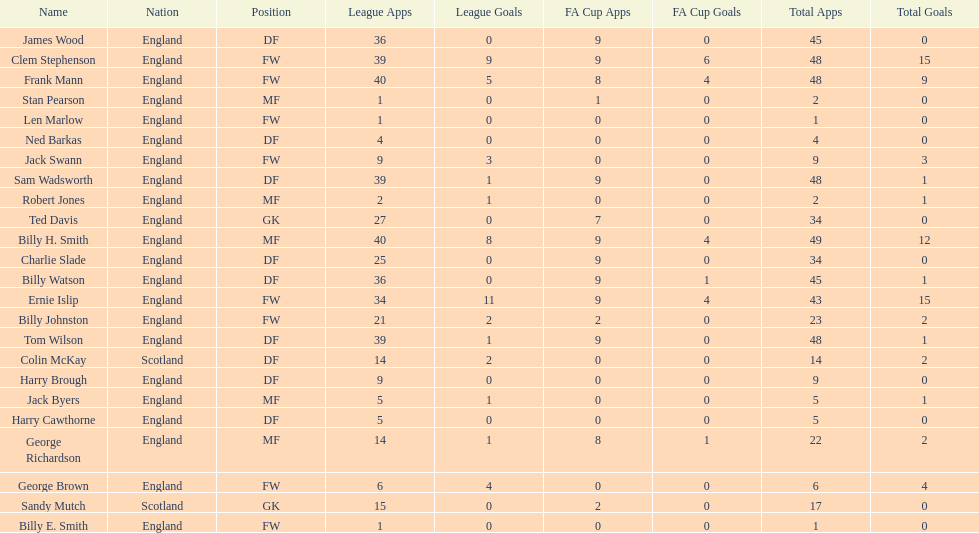What is the last name listed on this chart? James Wood. 